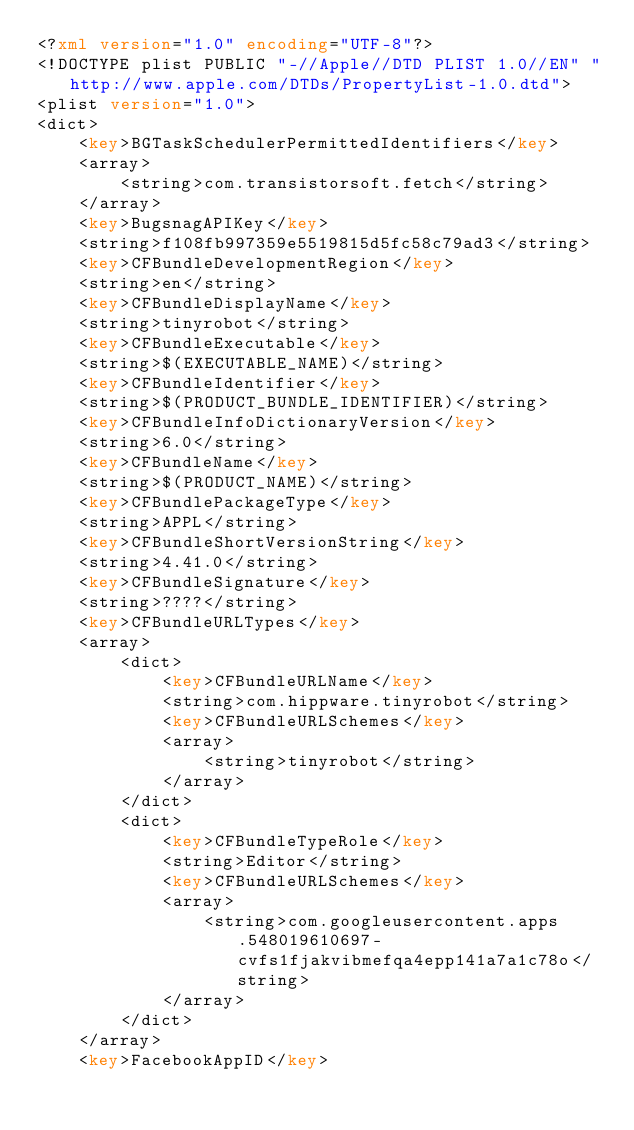Convert code to text. <code><loc_0><loc_0><loc_500><loc_500><_XML_><?xml version="1.0" encoding="UTF-8"?>
<!DOCTYPE plist PUBLIC "-//Apple//DTD PLIST 1.0//EN" "http://www.apple.com/DTDs/PropertyList-1.0.dtd">
<plist version="1.0">
<dict>
	<key>BGTaskSchedulerPermittedIdentifiers</key>
	<array>
		<string>com.transistorsoft.fetch</string>
	</array>
	<key>BugsnagAPIKey</key>
	<string>f108fb997359e5519815d5fc58c79ad3</string>
	<key>CFBundleDevelopmentRegion</key>
	<string>en</string>
	<key>CFBundleDisplayName</key>
	<string>tinyrobot</string>
	<key>CFBundleExecutable</key>
	<string>$(EXECUTABLE_NAME)</string>
	<key>CFBundleIdentifier</key>
	<string>$(PRODUCT_BUNDLE_IDENTIFIER)</string>
	<key>CFBundleInfoDictionaryVersion</key>
	<string>6.0</string>
	<key>CFBundleName</key>
	<string>$(PRODUCT_NAME)</string>
	<key>CFBundlePackageType</key>
	<string>APPL</string>
	<key>CFBundleShortVersionString</key>
	<string>4.41.0</string>
	<key>CFBundleSignature</key>
	<string>????</string>
	<key>CFBundleURLTypes</key>
	<array>
		<dict>
			<key>CFBundleURLName</key>
			<string>com.hippware.tinyrobot</string>
			<key>CFBundleURLSchemes</key>
			<array>
				<string>tinyrobot</string>
			</array>
		</dict>
		<dict>
			<key>CFBundleTypeRole</key>
			<string>Editor</string>
			<key>CFBundleURLSchemes</key>
			<array>
				<string>com.googleusercontent.apps.548019610697-cvfs1fjakvibmefqa4epp141a7a1c78o</string>
			</array>
		</dict>
	</array>
	<key>FacebookAppID</key></code> 